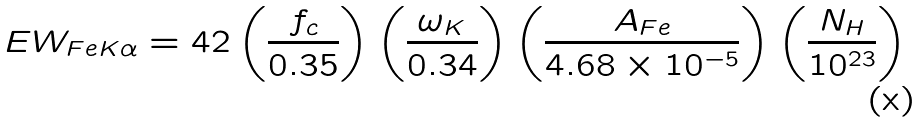<formula> <loc_0><loc_0><loc_500><loc_500>E W _ { F e K \alpha } = 4 2 \left ( \frac { f _ { c } } { 0 . 3 5 } \right ) \left ( \frac { \omega _ { K } } { 0 . 3 4 } \right ) \left ( \frac { A _ { F e } } { 4 . 6 8 \times 1 0 ^ { - 5 } } \right ) \left ( \frac { N _ { H } } { 1 0 ^ { 2 3 } } \right )</formula> 